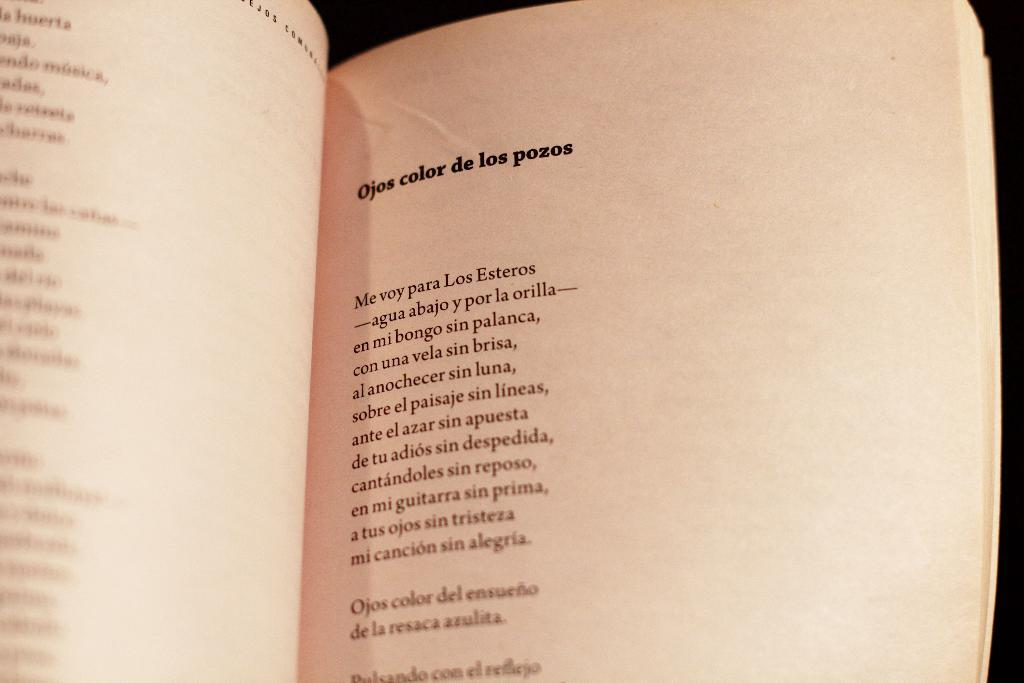Provide a one-sentence caption for the provided image. A page of a book titled Ojos color de los pozos. 